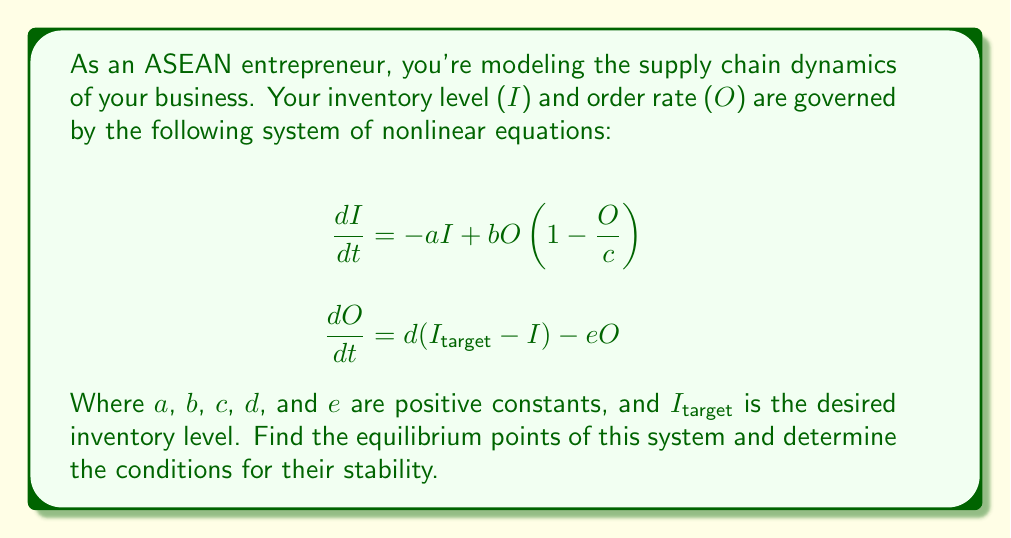What is the answer to this math problem? To solve this problem, we'll follow these steps:

1) Find the equilibrium points:
   At equilibrium, $\frac{dI}{dt} = 0$ and $\frac{dO}{dt} = 0$

   From $\frac{dI}{dt} = 0$:
   $$0 = -aI + bO(1-\frac{O}{c})$$

   From $\frac{dO}{dt} = 0$:
   $$0 = d(I_{target} - I) - eO$$
   $$I = I_{target} - \frac{e}{d}O$$

2) Substitute the expression for $I$ into the first equation:
   $$0 = -a(I_{target} - \frac{e}{d}O) + bO(1-\frac{O}{c})$$

3) Rearrange to get a quadratic equation in $O$:
   $$0 = -aI_{target} + (\frac{ae}{d} + b)O - \frac{b}{c}O^2$$

4) Solve this quadratic equation:
   $$O = \frac{(\frac{ae}{d} + b) \pm \sqrt{(\frac{ae}{d} + b)^2 + 4\frac{ab}{c}I_{target}}}{2\frac{b}{c}}$$

5) The equilibrium points are:
   $$(I^*, O^*) = (I_{target} - \frac{e}{d}O^*, O^*)$$
   where $O^*$ is given by the solution to the quadratic equation.

6) For stability, we need to analyze the Jacobian matrix at the equilibrium points:
   $$J = \begin{bmatrix} 
   -a & b(1-\frac{2O}{c}) \\
   -d & -e
   \end{bmatrix}$$

7) For stability, we need:
   - $tr(J) = -a-e < 0$ (always true as $a$ and $e$ are positive)
   - $det(J) = ae + bd(1-\frac{2O}{c}) > 0$

8) Therefore, the condition for stability is:
   $$O < \frac{c}{2}(1 + \frac{ae}{bd})$$

This condition must be checked for each equilibrium point found in step 5.
Answer: Equilibrium points: $(I^*, O^*) = (I_{target} - \frac{e}{d}O^*, O^*)$ where $O^* = \frac{(\frac{ae}{d} + b) \pm \sqrt{(\frac{ae}{d} + b)^2 + 4\frac{ab}{c}I_{target}}}{2\frac{b}{c}}$. Stability condition: $O^* < \frac{c}{2}(1 + \frac{ae}{bd})$. 